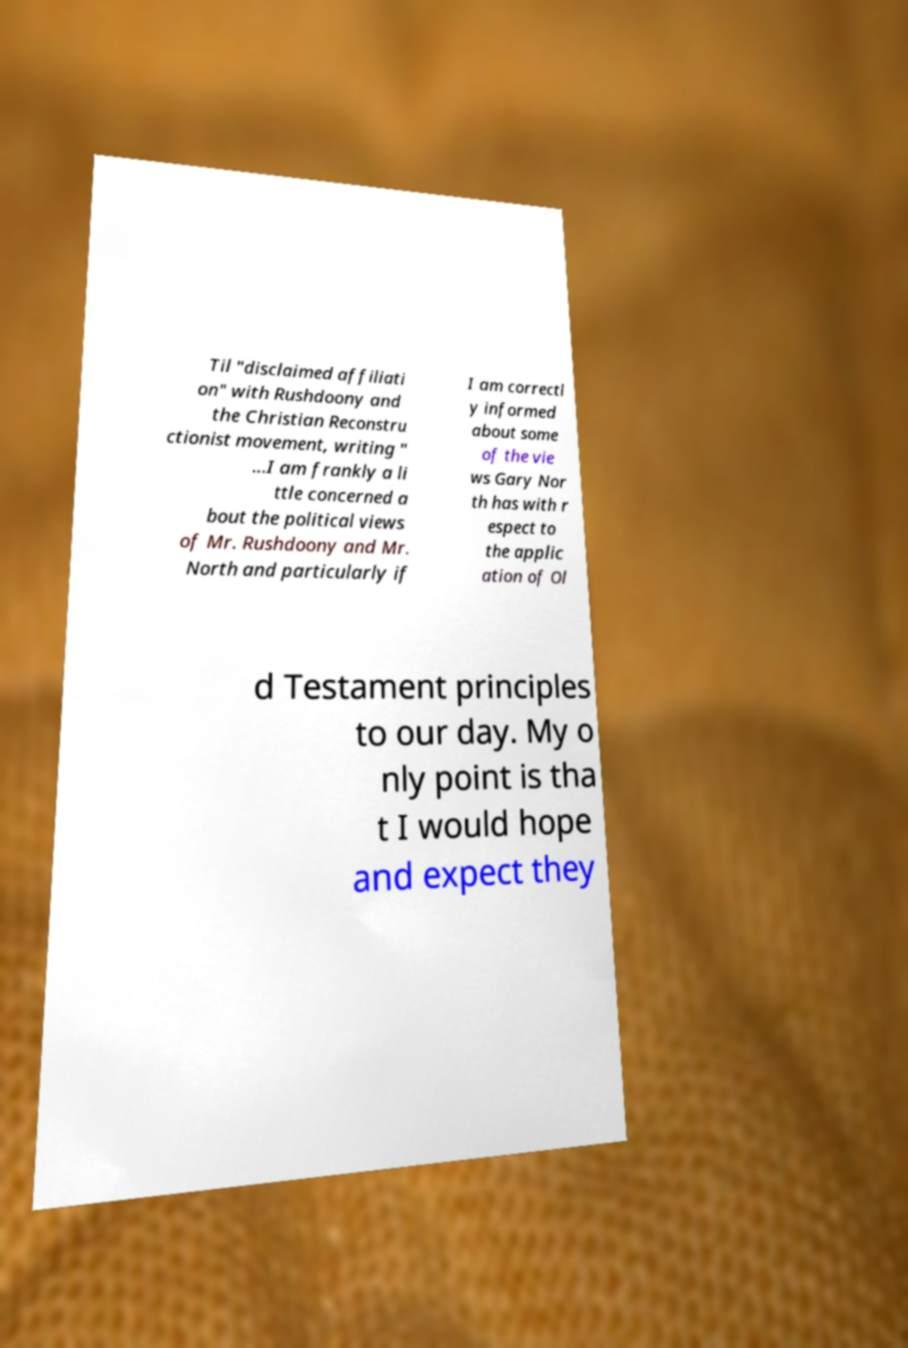Could you assist in decoding the text presented in this image and type it out clearly? Til "disclaimed affiliati on" with Rushdoony and the Christian Reconstru ctionist movement, writing " ...I am frankly a li ttle concerned a bout the political views of Mr. Rushdoony and Mr. North and particularly if I am correctl y informed about some of the vie ws Gary Nor th has with r espect to the applic ation of Ol d Testament principles to our day. My o nly point is tha t I would hope and expect they 